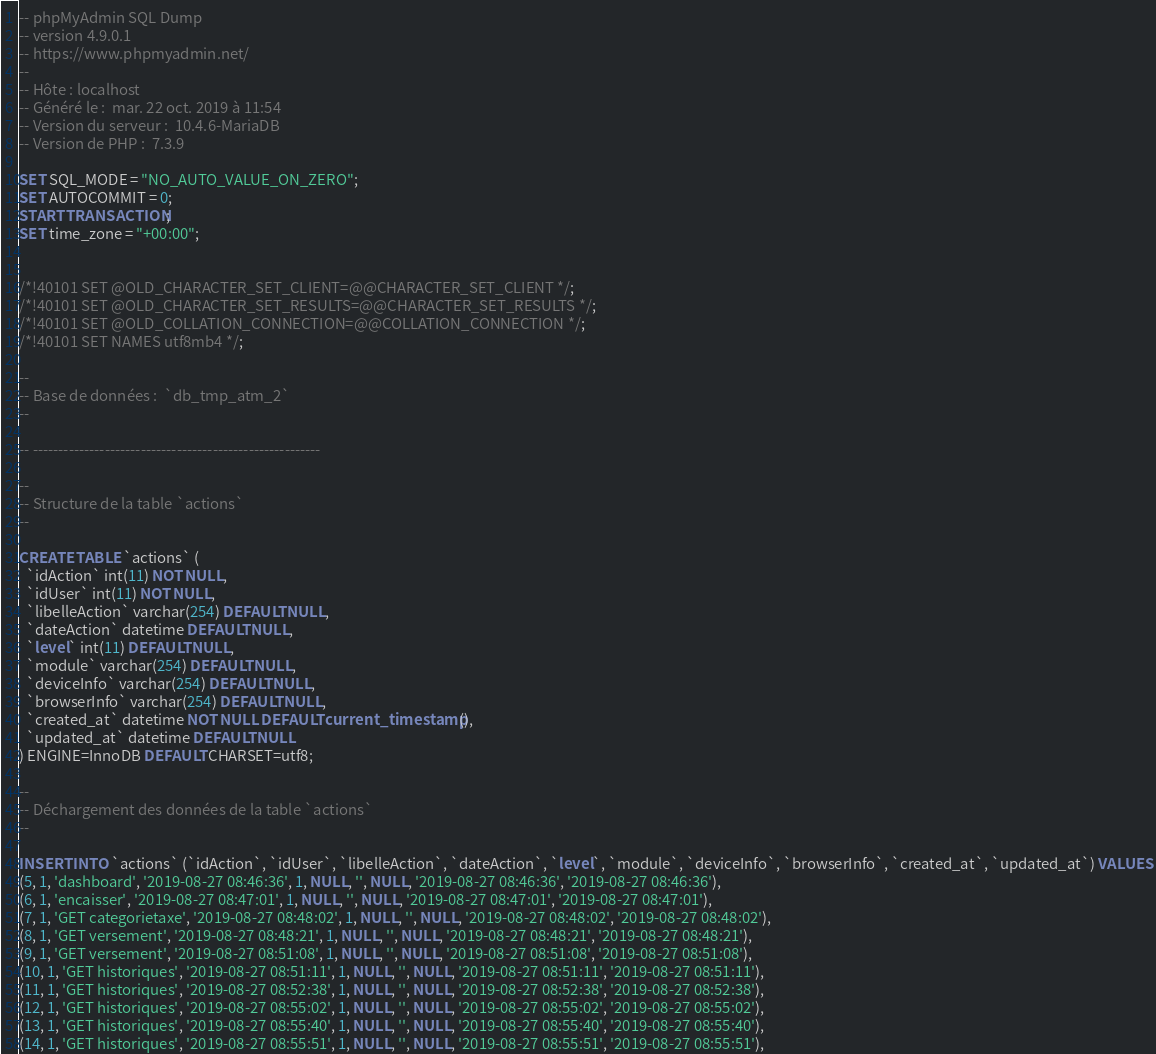Convert code to text. <code><loc_0><loc_0><loc_500><loc_500><_SQL_>-- phpMyAdmin SQL Dump
-- version 4.9.0.1
-- https://www.phpmyadmin.net/
--
-- Hôte : localhost
-- Généré le :  mar. 22 oct. 2019 à 11:54
-- Version du serveur :  10.4.6-MariaDB
-- Version de PHP :  7.3.9

SET SQL_MODE = "NO_AUTO_VALUE_ON_ZERO";
SET AUTOCOMMIT = 0;
START TRANSACTION;
SET time_zone = "+00:00";


/*!40101 SET @OLD_CHARACTER_SET_CLIENT=@@CHARACTER_SET_CLIENT */;
/*!40101 SET @OLD_CHARACTER_SET_RESULTS=@@CHARACTER_SET_RESULTS */;
/*!40101 SET @OLD_COLLATION_CONNECTION=@@COLLATION_CONNECTION */;
/*!40101 SET NAMES utf8mb4 */;

--
-- Base de données :  `db_tmp_atm_2`
--

-- --------------------------------------------------------

--
-- Structure de la table `actions`
--

CREATE TABLE `actions` (
  `idAction` int(11) NOT NULL,
  `idUser` int(11) NOT NULL,
  `libelleAction` varchar(254) DEFAULT NULL,
  `dateAction` datetime DEFAULT NULL,
  `level` int(11) DEFAULT NULL,
  `module` varchar(254) DEFAULT NULL,
  `deviceInfo` varchar(254) DEFAULT NULL,
  `browserInfo` varchar(254) DEFAULT NULL,
  `created_at` datetime NOT NULL DEFAULT current_timestamp(),
  `updated_at` datetime DEFAULT NULL
) ENGINE=InnoDB DEFAULT CHARSET=utf8;

--
-- Déchargement des données de la table `actions`
--

INSERT INTO `actions` (`idAction`, `idUser`, `libelleAction`, `dateAction`, `level`, `module`, `deviceInfo`, `browserInfo`, `created_at`, `updated_at`) VALUES
(5, 1, 'dashboard', '2019-08-27 08:46:36', 1, NULL, '', NULL, '2019-08-27 08:46:36', '2019-08-27 08:46:36'),
(6, 1, 'encaisser', '2019-08-27 08:47:01', 1, NULL, '', NULL, '2019-08-27 08:47:01', '2019-08-27 08:47:01'),
(7, 1, 'GET categorietaxe', '2019-08-27 08:48:02', 1, NULL, '', NULL, '2019-08-27 08:48:02', '2019-08-27 08:48:02'),
(8, 1, 'GET versement', '2019-08-27 08:48:21', 1, NULL, '', NULL, '2019-08-27 08:48:21', '2019-08-27 08:48:21'),
(9, 1, 'GET versement', '2019-08-27 08:51:08', 1, NULL, '', NULL, '2019-08-27 08:51:08', '2019-08-27 08:51:08'),
(10, 1, 'GET historiques', '2019-08-27 08:51:11', 1, NULL, '', NULL, '2019-08-27 08:51:11', '2019-08-27 08:51:11'),
(11, 1, 'GET historiques', '2019-08-27 08:52:38', 1, NULL, '', NULL, '2019-08-27 08:52:38', '2019-08-27 08:52:38'),
(12, 1, 'GET historiques', '2019-08-27 08:55:02', 1, NULL, '', NULL, '2019-08-27 08:55:02', '2019-08-27 08:55:02'),
(13, 1, 'GET historiques', '2019-08-27 08:55:40', 1, NULL, '', NULL, '2019-08-27 08:55:40', '2019-08-27 08:55:40'),
(14, 1, 'GET historiques', '2019-08-27 08:55:51', 1, NULL, '', NULL, '2019-08-27 08:55:51', '2019-08-27 08:55:51'),</code> 